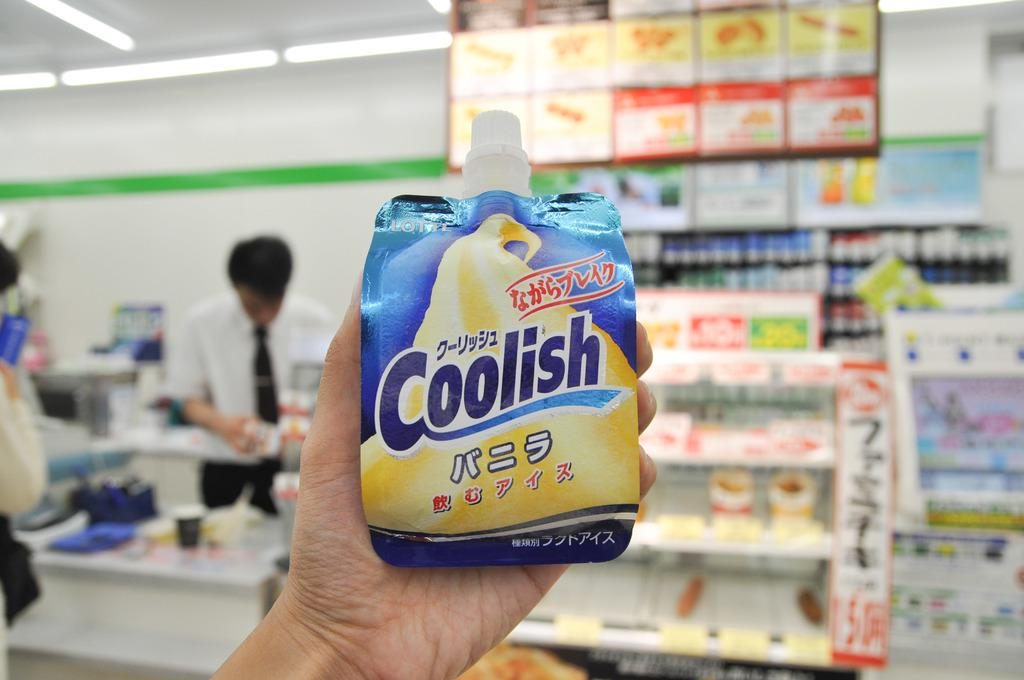<image>
Share a concise interpretation of the image provided. an item that has the word coolish on it 